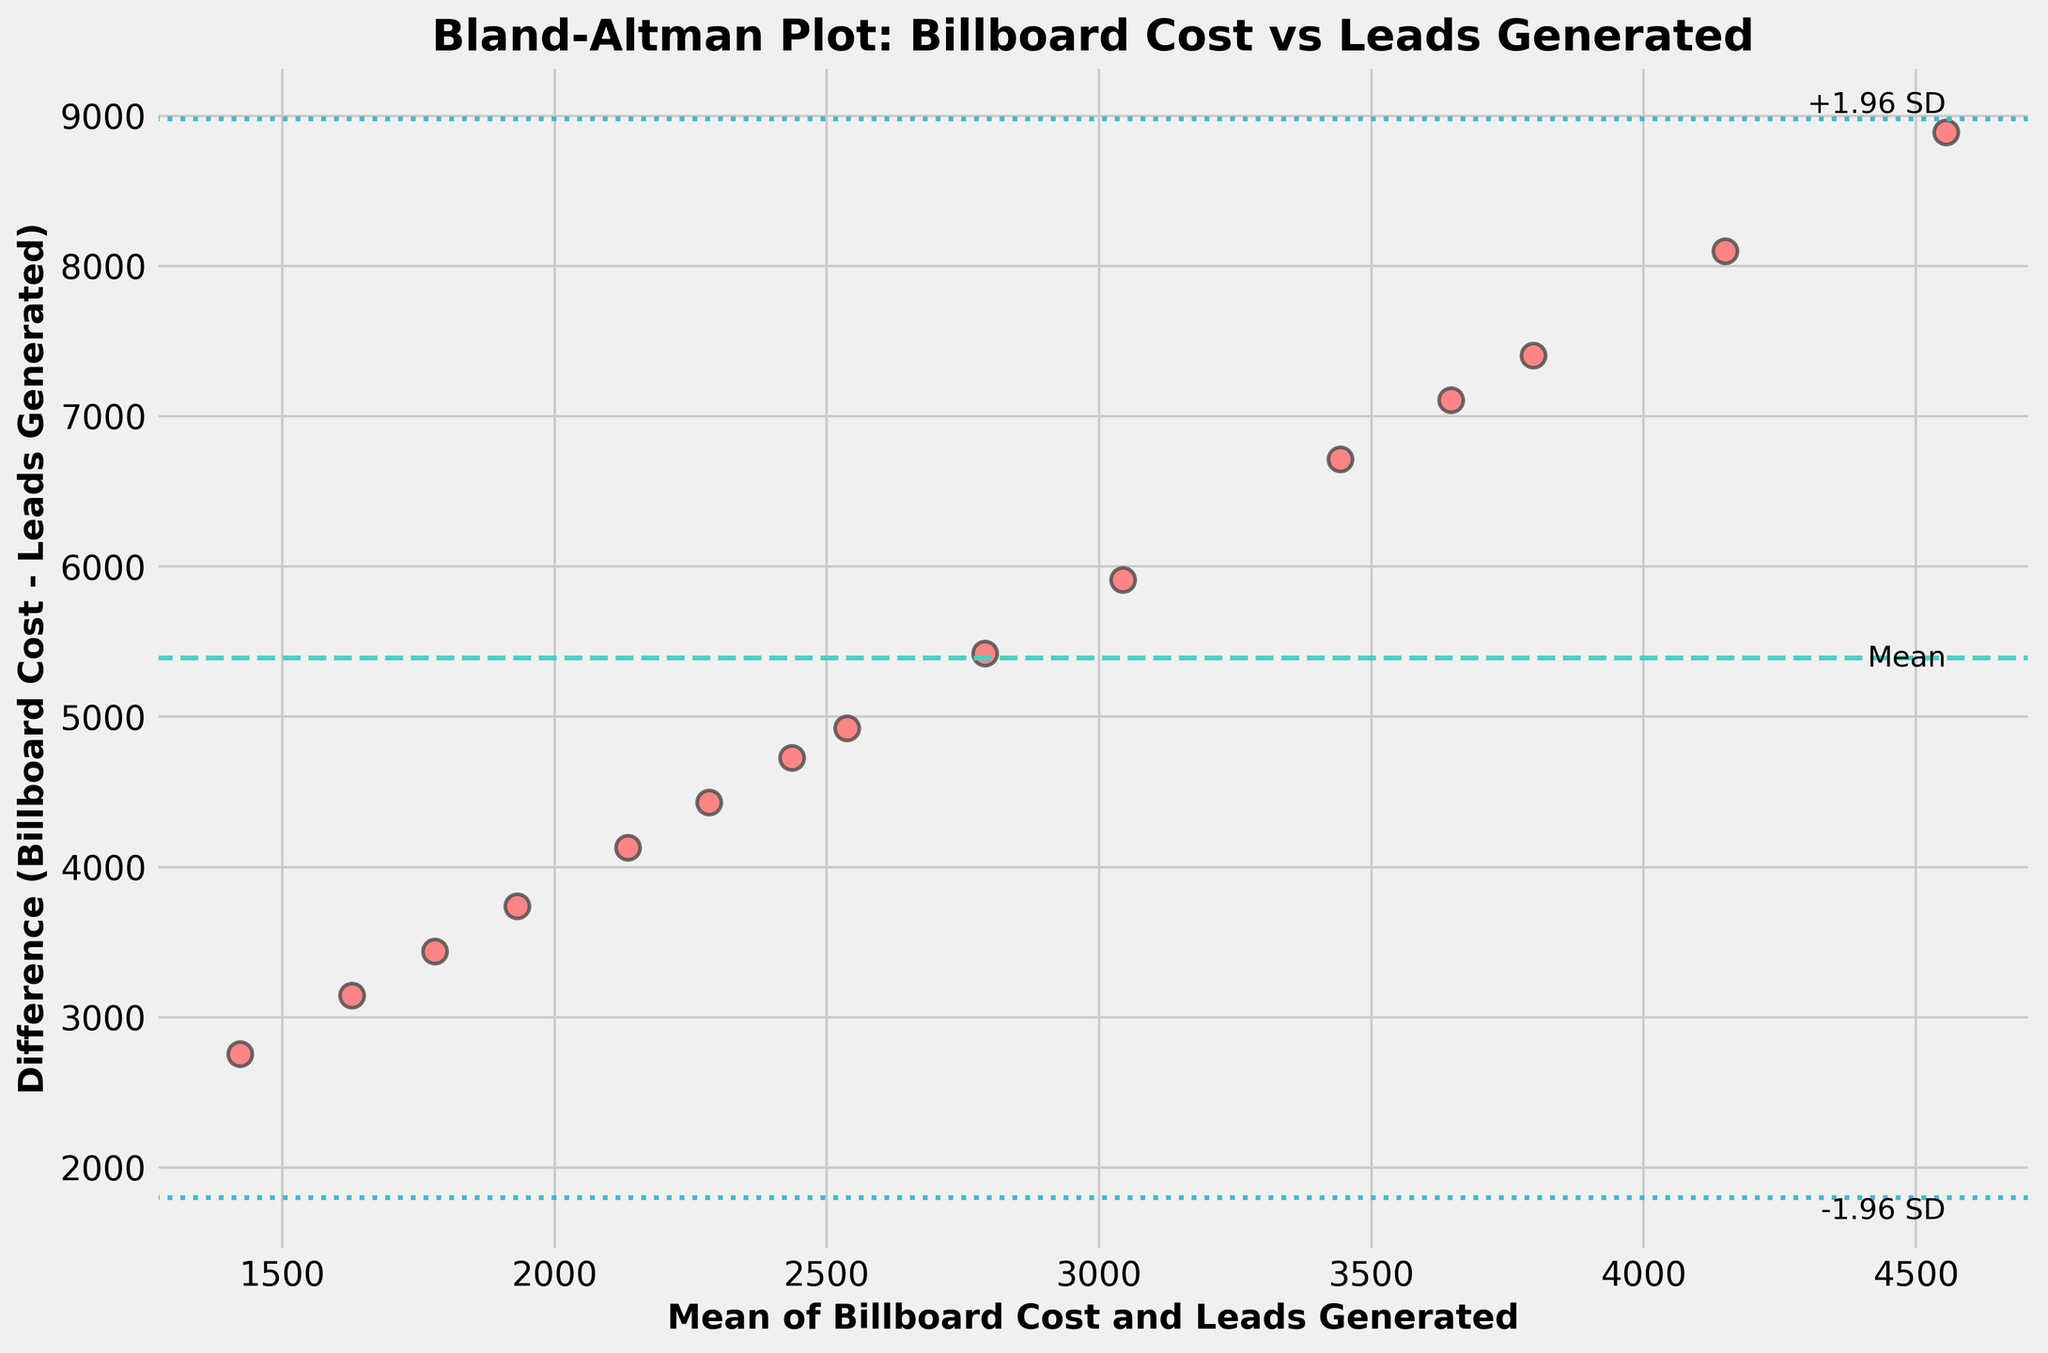What is the title of the plot? The title of the plot is usually displayed at the top of the figure. Here, the title is indicated as "Bland-Altman Plot: Billboard Cost vs Leads Generated" based on the provided code.
Answer: Bland-Altman Plot: Billboard Cost vs Leads Generated How many data points are plotted? The number of data points corresponds to the individual points shown in the scatter plot. In this case, the data provided has 15 entries, so there should be 15 data points in the plot.
Answer: 15 What does the horizontal dashed line represent? The horizontal dashed line represents the mean difference between Billboard Cost and Leads Generated. This line helps to visualize the average bias.
Answer: Mean difference What are the horizontal dotted lines used for? The horizontal dotted lines represent the limits of agreement, which are calculated as the mean difference plus and minus 1.96 times the standard deviation of the differences. These lines help in assessing the variability and agreement.
Answer: Limits of agreement What is the maximum value on the x-axis (Mean of Billboard Cost and Leads Generated)? To find the maximum value on the x-axis, we take the highest value from the 'Average' column of the data provided. The maximum value is 4555.
Answer: 4555 How do the limits of agreement help interpret the plot? The limits of agreement help identify the range within which most differences between Billboard Cost and Leads Generated will lie. If the differences fall within these limits, it indicates acceptable agreement.
Answer: Indicate acceptable agreement Are there any outliers in the plotted differences? Outliers would be points that fall outside the limits of agreement (the horizontal dotted lines). By examining the plot, one can check if any points fall beyond these lines.
Answer: Depends on plot inspection Which data point has the largest difference between Billboard Cost and Leads Generated? The largest difference is identified by finding the point with the highest vertical deviation from the horizontal mean difference line. This information derives from visual inspection of the plotted points.
Answer: Depends on plot inspection Does the plot show any systematic bias between Billboard Cost and Leads Generated? A systematic bias would be indicated if most points fall consistently on one side of the mean difference line. Examining the plot would determine if such a pattern exists.
Answer: Depends on plot inspection 